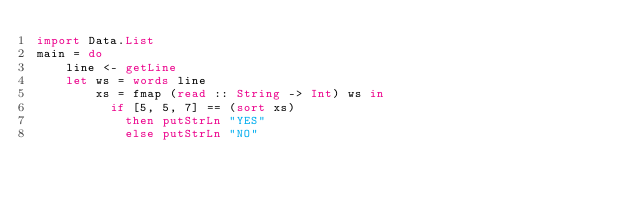<code> <loc_0><loc_0><loc_500><loc_500><_Haskell_>import Data.List
main = do
    line <- getLine
    let ws = words line
        xs = fmap (read :: String -> Int) ws in
          if [5, 5, 7] == (sort xs)
            then putStrLn "YES"
            else putStrLn "NO"
</code> 